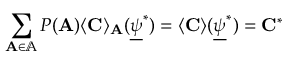<formula> <loc_0><loc_0><loc_500><loc_500>\sum _ { A \in \mathbb { A } } P ( A ) \langle C \rangle _ { A } ( \underline { \psi } ^ { * } ) = \langle C \rangle ( \underline { \psi } ^ { * } ) = C ^ { * }</formula> 